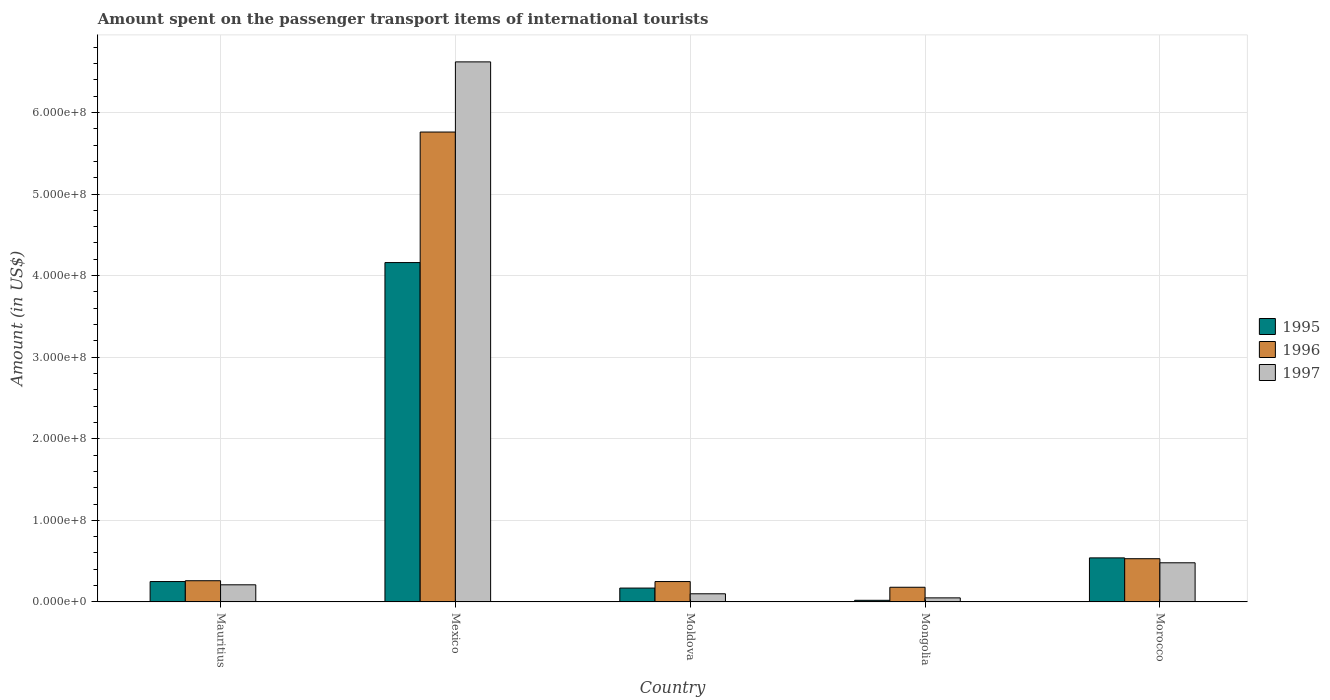How many different coloured bars are there?
Your answer should be compact. 3. Are the number of bars per tick equal to the number of legend labels?
Your response must be concise. Yes. Are the number of bars on each tick of the X-axis equal?
Provide a succinct answer. Yes. How many bars are there on the 2nd tick from the left?
Offer a very short reply. 3. What is the label of the 1st group of bars from the left?
Provide a succinct answer. Mauritius. In how many cases, is the number of bars for a given country not equal to the number of legend labels?
Make the answer very short. 0. What is the amount spent on the passenger transport items of international tourists in 1997 in Mongolia?
Provide a short and direct response. 5.00e+06. Across all countries, what is the maximum amount spent on the passenger transport items of international tourists in 1996?
Offer a very short reply. 5.76e+08. Across all countries, what is the minimum amount spent on the passenger transport items of international tourists in 1997?
Give a very brief answer. 5.00e+06. In which country was the amount spent on the passenger transport items of international tourists in 1996 minimum?
Your response must be concise. Mongolia. What is the total amount spent on the passenger transport items of international tourists in 1996 in the graph?
Provide a succinct answer. 6.98e+08. What is the difference between the amount spent on the passenger transport items of international tourists in 1997 in Mexico and that in Moldova?
Offer a terse response. 6.52e+08. What is the difference between the amount spent on the passenger transport items of international tourists in 1997 in Moldova and the amount spent on the passenger transport items of international tourists in 1996 in Morocco?
Keep it short and to the point. -4.30e+07. What is the average amount spent on the passenger transport items of international tourists in 1996 per country?
Your response must be concise. 1.40e+08. What is the difference between the amount spent on the passenger transport items of international tourists of/in 1997 and amount spent on the passenger transport items of international tourists of/in 1995 in Morocco?
Your answer should be compact. -6.00e+06. What is the ratio of the amount spent on the passenger transport items of international tourists in 1997 in Mongolia to that in Morocco?
Make the answer very short. 0.1. What is the difference between the highest and the second highest amount spent on the passenger transport items of international tourists in 1997?
Make the answer very short. 6.14e+08. What is the difference between the highest and the lowest amount spent on the passenger transport items of international tourists in 1997?
Ensure brevity in your answer.  6.57e+08. In how many countries, is the amount spent on the passenger transport items of international tourists in 1997 greater than the average amount spent on the passenger transport items of international tourists in 1997 taken over all countries?
Ensure brevity in your answer.  1. What does the 2nd bar from the left in Mongolia represents?
Your answer should be compact. 1996. What does the 2nd bar from the right in Mongolia represents?
Your response must be concise. 1996. Is it the case that in every country, the sum of the amount spent on the passenger transport items of international tourists in 1995 and amount spent on the passenger transport items of international tourists in 1997 is greater than the amount spent on the passenger transport items of international tourists in 1996?
Make the answer very short. No. Are all the bars in the graph horizontal?
Provide a succinct answer. No. How many countries are there in the graph?
Your answer should be compact. 5. Does the graph contain grids?
Your answer should be compact. Yes. How many legend labels are there?
Your answer should be very brief. 3. How are the legend labels stacked?
Your answer should be compact. Vertical. What is the title of the graph?
Your response must be concise. Amount spent on the passenger transport items of international tourists. What is the label or title of the Y-axis?
Give a very brief answer. Amount (in US$). What is the Amount (in US$) in 1995 in Mauritius?
Provide a short and direct response. 2.50e+07. What is the Amount (in US$) in 1996 in Mauritius?
Offer a very short reply. 2.60e+07. What is the Amount (in US$) of 1997 in Mauritius?
Provide a short and direct response. 2.10e+07. What is the Amount (in US$) of 1995 in Mexico?
Give a very brief answer. 4.16e+08. What is the Amount (in US$) of 1996 in Mexico?
Keep it short and to the point. 5.76e+08. What is the Amount (in US$) of 1997 in Mexico?
Give a very brief answer. 6.62e+08. What is the Amount (in US$) in 1995 in Moldova?
Your response must be concise. 1.70e+07. What is the Amount (in US$) in 1996 in Moldova?
Keep it short and to the point. 2.50e+07. What is the Amount (in US$) of 1997 in Moldova?
Offer a very short reply. 1.00e+07. What is the Amount (in US$) in 1996 in Mongolia?
Your answer should be compact. 1.80e+07. What is the Amount (in US$) in 1995 in Morocco?
Your answer should be very brief. 5.40e+07. What is the Amount (in US$) of 1996 in Morocco?
Provide a succinct answer. 5.30e+07. What is the Amount (in US$) of 1997 in Morocco?
Provide a short and direct response. 4.80e+07. Across all countries, what is the maximum Amount (in US$) of 1995?
Ensure brevity in your answer.  4.16e+08. Across all countries, what is the maximum Amount (in US$) in 1996?
Your answer should be very brief. 5.76e+08. Across all countries, what is the maximum Amount (in US$) of 1997?
Ensure brevity in your answer.  6.62e+08. Across all countries, what is the minimum Amount (in US$) in 1996?
Your answer should be very brief. 1.80e+07. What is the total Amount (in US$) in 1995 in the graph?
Ensure brevity in your answer.  5.14e+08. What is the total Amount (in US$) in 1996 in the graph?
Make the answer very short. 6.98e+08. What is the total Amount (in US$) in 1997 in the graph?
Your answer should be compact. 7.46e+08. What is the difference between the Amount (in US$) of 1995 in Mauritius and that in Mexico?
Provide a succinct answer. -3.91e+08. What is the difference between the Amount (in US$) of 1996 in Mauritius and that in Mexico?
Keep it short and to the point. -5.50e+08. What is the difference between the Amount (in US$) of 1997 in Mauritius and that in Mexico?
Your answer should be very brief. -6.41e+08. What is the difference between the Amount (in US$) in 1995 in Mauritius and that in Moldova?
Offer a terse response. 8.00e+06. What is the difference between the Amount (in US$) in 1997 in Mauritius and that in Moldova?
Provide a succinct answer. 1.10e+07. What is the difference between the Amount (in US$) of 1995 in Mauritius and that in Mongolia?
Your answer should be very brief. 2.30e+07. What is the difference between the Amount (in US$) of 1996 in Mauritius and that in Mongolia?
Provide a short and direct response. 8.00e+06. What is the difference between the Amount (in US$) in 1997 in Mauritius and that in Mongolia?
Offer a terse response. 1.60e+07. What is the difference between the Amount (in US$) of 1995 in Mauritius and that in Morocco?
Provide a short and direct response. -2.90e+07. What is the difference between the Amount (in US$) in 1996 in Mauritius and that in Morocco?
Provide a succinct answer. -2.70e+07. What is the difference between the Amount (in US$) in 1997 in Mauritius and that in Morocco?
Your answer should be compact. -2.70e+07. What is the difference between the Amount (in US$) in 1995 in Mexico and that in Moldova?
Offer a terse response. 3.99e+08. What is the difference between the Amount (in US$) of 1996 in Mexico and that in Moldova?
Make the answer very short. 5.51e+08. What is the difference between the Amount (in US$) in 1997 in Mexico and that in Moldova?
Provide a short and direct response. 6.52e+08. What is the difference between the Amount (in US$) of 1995 in Mexico and that in Mongolia?
Offer a very short reply. 4.14e+08. What is the difference between the Amount (in US$) of 1996 in Mexico and that in Mongolia?
Offer a terse response. 5.58e+08. What is the difference between the Amount (in US$) in 1997 in Mexico and that in Mongolia?
Keep it short and to the point. 6.57e+08. What is the difference between the Amount (in US$) of 1995 in Mexico and that in Morocco?
Your response must be concise. 3.62e+08. What is the difference between the Amount (in US$) of 1996 in Mexico and that in Morocco?
Offer a terse response. 5.23e+08. What is the difference between the Amount (in US$) of 1997 in Mexico and that in Morocco?
Your answer should be compact. 6.14e+08. What is the difference between the Amount (in US$) in 1995 in Moldova and that in Mongolia?
Provide a short and direct response. 1.50e+07. What is the difference between the Amount (in US$) in 1997 in Moldova and that in Mongolia?
Offer a very short reply. 5.00e+06. What is the difference between the Amount (in US$) in 1995 in Moldova and that in Morocco?
Your answer should be very brief. -3.70e+07. What is the difference between the Amount (in US$) of 1996 in Moldova and that in Morocco?
Give a very brief answer. -2.80e+07. What is the difference between the Amount (in US$) in 1997 in Moldova and that in Morocco?
Your answer should be very brief. -3.80e+07. What is the difference between the Amount (in US$) of 1995 in Mongolia and that in Morocco?
Your answer should be compact. -5.20e+07. What is the difference between the Amount (in US$) in 1996 in Mongolia and that in Morocco?
Keep it short and to the point. -3.50e+07. What is the difference between the Amount (in US$) of 1997 in Mongolia and that in Morocco?
Your answer should be very brief. -4.30e+07. What is the difference between the Amount (in US$) of 1995 in Mauritius and the Amount (in US$) of 1996 in Mexico?
Ensure brevity in your answer.  -5.51e+08. What is the difference between the Amount (in US$) of 1995 in Mauritius and the Amount (in US$) of 1997 in Mexico?
Your answer should be very brief. -6.37e+08. What is the difference between the Amount (in US$) in 1996 in Mauritius and the Amount (in US$) in 1997 in Mexico?
Provide a succinct answer. -6.36e+08. What is the difference between the Amount (in US$) of 1995 in Mauritius and the Amount (in US$) of 1997 in Moldova?
Your answer should be compact. 1.50e+07. What is the difference between the Amount (in US$) of 1996 in Mauritius and the Amount (in US$) of 1997 in Moldova?
Give a very brief answer. 1.60e+07. What is the difference between the Amount (in US$) of 1996 in Mauritius and the Amount (in US$) of 1997 in Mongolia?
Keep it short and to the point. 2.10e+07. What is the difference between the Amount (in US$) of 1995 in Mauritius and the Amount (in US$) of 1996 in Morocco?
Offer a very short reply. -2.80e+07. What is the difference between the Amount (in US$) in 1995 in Mauritius and the Amount (in US$) in 1997 in Morocco?
Provide a succinct answer. -2.30e+07. What is the difference between the Amount (in US$) of 1996 in Mauritius and the Amount (in US$) of 1997 in Morocco?
Keep it short and to the point. -2.20e+07. What is the difference between the Amount (in US$) of 1995 in Mexico and the Amount (in US$) of 1996 in Moldova?
Keep it short and to the point. 3.91e+08. What is the difference between the Amount (in US$) in 1995 in Mexico and the Amount (in US$) in 1997 in Moldova?
Ensure brevity in your answer.  4.06e+08. What is the difference between the Amount (in US$) of 1996 in Mexico and the Amount (in US$) of 1997 in Moldova?
Keep it short and to the point. 5.66e+08. What is the difference between the Amount (in US$) in 1995 in Mexico and the Amount (in US$) in 1996 in Mongolia?
Offer a terse response. 3.98e+08. What is the difference between the Amount (in US$) of 1995 in Mexico and the Amount (in US$) of 1997 in Mongolia?
Provide a short and direct response. 4.11e+08. What is the difference between the Amount (in US$) in 1996 in Mexico and the Amount (in US$) in 1997 in Mongolia?
Give a very brief answer. 5.71e+08. What is the difference between the Amount (in US$) in 1995 in Mexico and the Amount (in US$) in 1996 in Morocco?
Offer a very short reply. 3.63e+08. What is the difference between the Amount (in US$) in 1995 in Mexico and the Amount (in US$) in 1997 in Morocco?
Ensure brevity in your answer.  3.68e+08. What is the difference between the Amount (in US$) in 1996 in Mexico and the Amount (in US$) in 1997 in Morocco?
Your answer should be compact. 5.28e+08. What is the difference between the Amount (in US$) in 1995 in Moldova and the Amount (in US$) in 1996 in Mongolia?
Provide a succinct answer. -1.00e+06. What is the difference between the Amount (in US$) of 1995 in Moldova and the Amount (in US$) of 1997 in Mongolia?
Give a very brief answer. 1.20e+07. What is the difference between the Amount (in US$) of 1995 in Moldova and the Amount (in US$) of 1996 in Morocco?
Offer a terse response. -3.60e+07. What is the difference between the Amount (in US$) in 1995 in Moldova and the Amount (in US$) in 1997 in Morocco?
Give a very brief answer. -3.10e+07. What is the difference between the Amount (in US$) of 1996 in Moldova and the Amount (in US$) of 1997 in Morocco?
Provide a short and direct response. -2.30e+07. What is the difference between the Amount (in US$) of 1995 in Mongolia and the Amount (in US$) of 1996 in Morocco?
Your answer should be compact. -5.10e+07. What is the difference between the Amount (in US$) of 1995 in Mongolia and the Amount (in US$) of 1997 in Morocco?
Provide a short and direct response. -4.60e+07. What is the difference between the Amount (in US$) in 1996 in Mongolia and the Amount (in US$) in 1997 in Morocco?
Provide a short and direct response. -3.00e+07. What is the average Amount (in US$) in 1995 per country?
Keep it short and to the point. 1.03e+08. What is the average Amount (in US$) of 1996 per country?
Give a very brief answer. 1.40e+08. What is the average Amount (in US$) of 1997 per country?
Offer a terse response. 1.49e+08. What is the difference between the Amount (in US$) in 1996 and Amount (in US$) in 1997 in Mauritius?
Offer a terse response. 5.00e+06. What is the difference between the Amount (in US$) in 1995 and Amount (in US$) in 1996 in Mexico?
Keep it short and to the point. -1.60e+08. What is the difference between the Amount (in US$) in 1995 and Amount (in US$) in 1997 in Mexico?
Ensure brevity in your answer.  -2.46e+08. What is the difference between the Amount (in US$) in 1996 and Amount (in US$) in 1997 in Mexico?
Your response must be concise. -8.60e+07. What is the difference between the Amount (in US$) in 1995 and Amount (in US$) in 1996 in Moldova?
Keep it short and to the point. -8.00e+06. What is the difference between the Amount (in US$) of 1996 and Amount (in US$) of 1997 in Moldova?
Provide a succinct answer. 1.50e+07. What is the difference between the Amount (in US$) of 1995 and Amount (in US$) of 1996 in Mongolia?
Keep it short and to the point. -1.60e+07. What is the difference between the Amount (in US$) of 1995 and Amount (in US$) of 1997 in Mongolia?
Provide a succinct answer. -3.00e+06. What is the difference between the Amount (in US$) in 1996 and Amount (in US$) in 1997 in Mongolia?
Your answer should be very brief. 1.30e+07. What is the difference between the Amount (in US$) in 1995 and Amount (in US$) in 1996 in Morocco?
Keep it short and to the point. 1.00e+06. What is the difference between the Amount (in US$) of 1995 and Amount (in US$) of 1997 in Morocco?
Provide a succinct answer. 6.00e+06. What is the ratio of the Amount (in US$) of 1995 in Mauritius to that in Mexico?
Keep it short and to the point. 0.06. What is the ratio of the Amount (in US$) in 1996 in Mauritius to that in Mexico?
Offer a very short reply. 0.05. What is the ratio of the Amount (in US$) of 1997 in Mauritius to that in Mexico?
Give a very brief answer. 0.03. What is the ratio of the Amount (in US$) in 1995 in Mauritius to that in Moldova?
Keep it short and to the point. 1.47. What is the ratio of the Amount (in US$) of 1997 in Mauritius to that in Moldova?
Offer a terse response. 2.1. What is the ratio of the Amount (in US$) of 1996 in Mauritius to that in Mongolia?
Give a very brief answer. 1.44. What is the ratio of the Amount (in US$) of 1995 in Mauritius to that in Morocco?
Offer a terse response. 0.46. What is the ratio of the Amount (in US$) in 1996 in Mauritius to that in Morocco?
Your answer should be very brief. 0.49. What is the ratio of the Amount (in US$) of 1997 in Mauritius to that in Morocco?
Your response must be concise. 0.44. What is the ratio of the Amount (in US$) of 1995 in Mexico to that in Moldova?
Your answer should be compact. 24.47. What is the ratio of the Amount (in US$) of 1996 in Mexico to that in Moldova?
Your response must be concise. 23.04. What is the ratio of the Amount (in US$) of 1997 in Mexico to that in Moldova?
Offer a very short reply. 66.2. What is the ratio of the Amount (in US$) in 1995 in Mexico to that in Mongolia?
Offer a very short reply. 208. What is the ratio of the Amount (in US$) in 1996 in Mexico to that in Mongolia?
Your answer should be compact. 32. What is the ratio of the Amount (in US$) of 1997 in Mexico to that in Mongolia?
Your answer should be compact. 132.4. What is the ratio of the Amount (in US$) of 1995 in Mexico to that in Morocco?
Keep it short and to the point. 7.7. What is the ratio of the Amount (in US$) of 1996 in Mexico to that in Morocco?
Provide a short and direct response. 10.87. What is the ratio of the Amount (in US$) of 1997 in Mexico to that in Morocco?
Make the answer very short. 13.79. What is the ratio of the Amount (in US$) of 1995 in Moldova to that in Mongolia?
Provide a short and direct response. 8.5. What is the ratio of the Amount (in US$) of 1996 in Moldova to that in Mongolia?
Provide a succinct answer. 1.39. What is the ratio of the Amount (in US$) of 1997 in Moldova to that in Mongolia?
Your answer should be compact. 2. What is the ratio of the Amount (in US$) in 1995 in Moldova to that in Morocco?
Provide a succinct answer. 0.31. What is the ratio of the Amount (in US$) in 1996 in Moldova to that in Morocco?
Your response must be concise. 0.47. What is the ratio of the Amount (in US$) of 1997 in Moldova to that in Morocco?
Give a very brief answer. 0.21. What is the ratio of the Amount (in US$) of 1995 in Mongolia to that in Morocco?
Offer a terse response. 0.04. What is the ratio of the Amount (in US$) of 1996 in Mongolia to that in Morocco?
Provide a short and direct response. 0.34. What is the ratio of the Amount (in US$) in 1997 in Mongolia to that in Morocco?
Give a very brief answer. 0.1. What is the difference between the highest and the second highest Amount (in US$) of 1995?
Your response must be concise. 3.62e+08. What is the difference between the highest and the second highest Amount (in US$) in 1996?
Your answer should be very brief. 5.23e+08. What is the difference between the highest and the second highest Amount (in US$) of 1997?
Offer a terse response. 6.14e+08. What is the difference between the highest and the lowest Amount (in US$) in 1995?
Provide a short and direct response. 4.14e+08. What is the difference between the highest and the lowest Amount (in US$) in 1996?
Your answer should be very brief. 5.58e+08. What is the difference between the highest and the lowest Amount (in US$) of 1997?
Keep it short and to the point. 6.57e+08. 